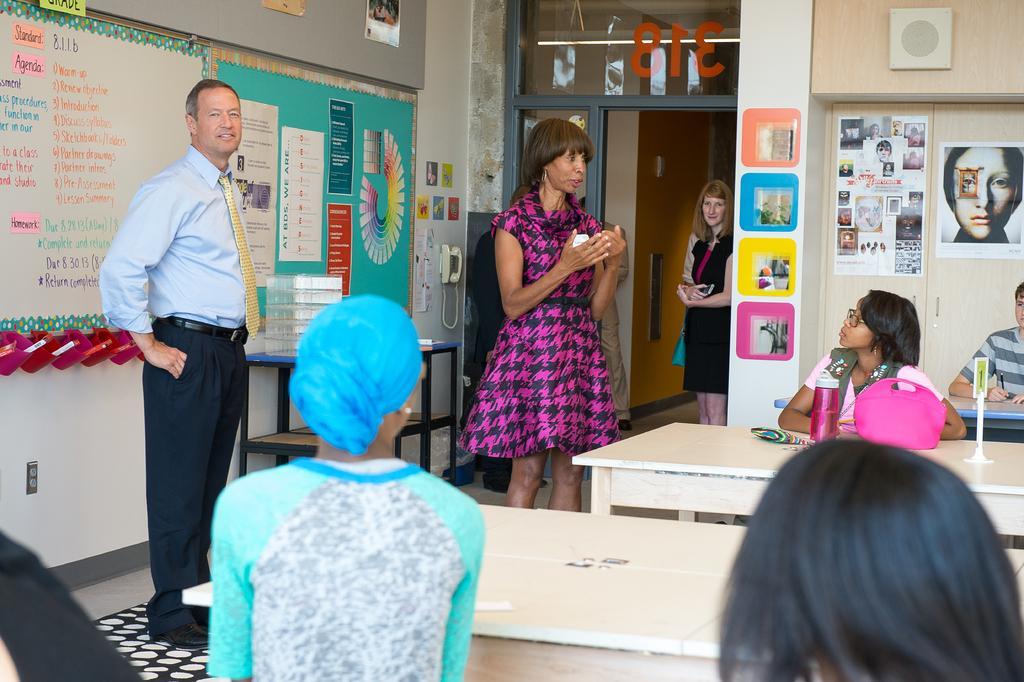Can you describe this image briefly? In this image I can see there are three persons standing on the floor and I can see four persons sitting in front of the bench, on the bench I can see a pink color bottle and pink color bag and on the left side person his is smiling ,in the middle woman wearing a pink color skirt she is explaining something , at the top I can see the wall and notice boards and images of persons attached to the wall, in the middle I can see a table , on the table I can see boxes. 